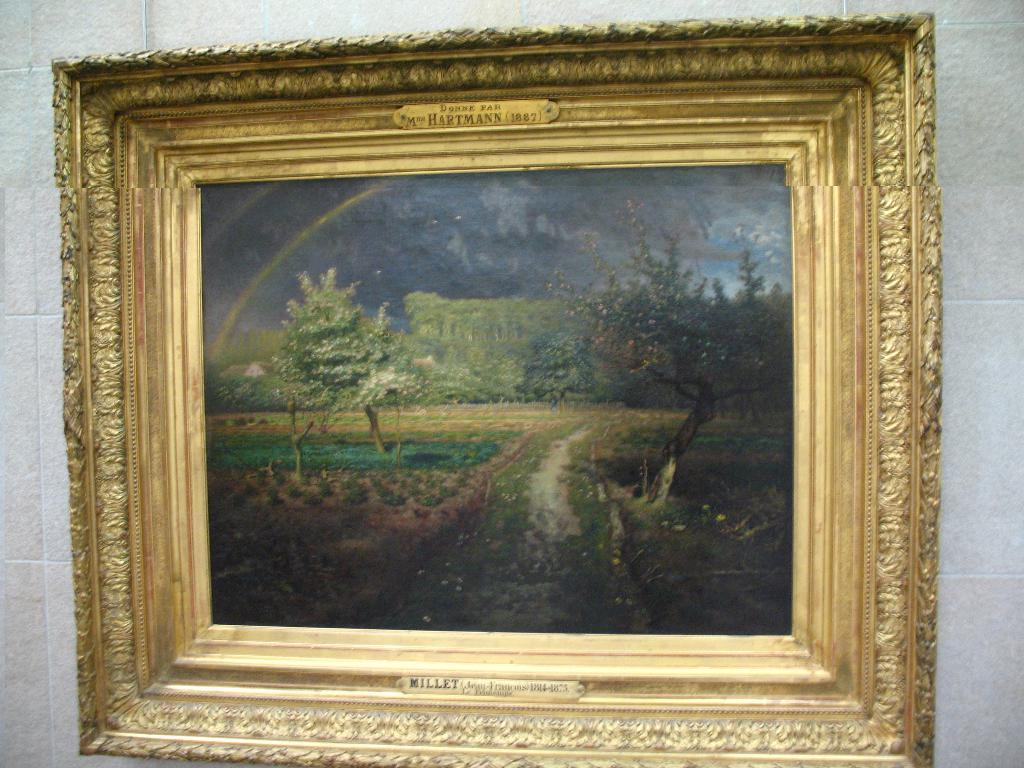What object is present in the image that typically holds a photograph? There is a photo frame in the image. Where is the photo frame located? The photo frame is on a wall. What is depicted within the photo frame? The photo frame contains a group of trees. What part of the natural environment can be seen within the photo frame? The sky is visible within the photo frame. What type of base is used to support the religious wax sculptures in the image? There are no religious wax sculptures present in the image. 